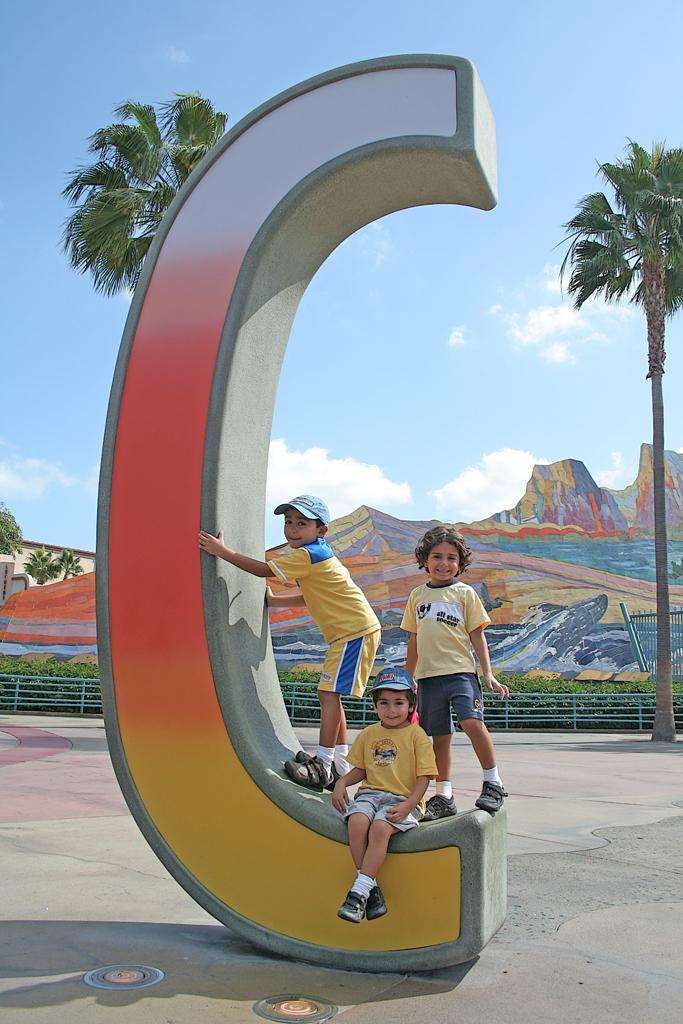What are the people in the image doing? The people in the image are standing and sitting. What can be seen in front of the people? There is a wall in the image. What is located behind the wall? Behind the wall, there is fencing, plants, and trees. What is visible in the background of the image? Hills are visible in the background of the image. What is the condition of the sky in the image? Clouds are present in the sky, and the sky is visible in the image. What type of card is being used by the people in the image to communicate with their partner? There is no card or partner present in the image. How many rolls of fabric are visible in the image? There are no rolls of fabric present in the image. 